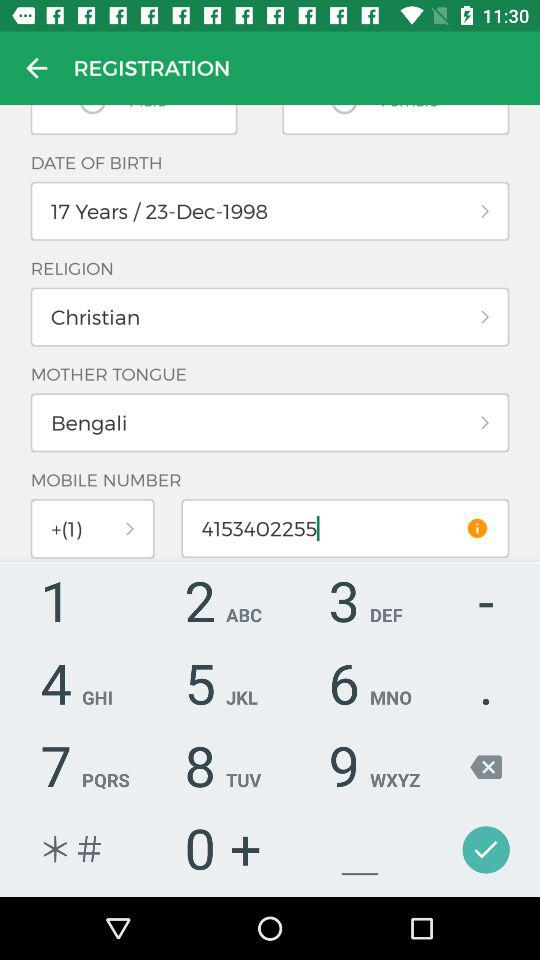What is the profile name under which I can log in? The profile name is John. 